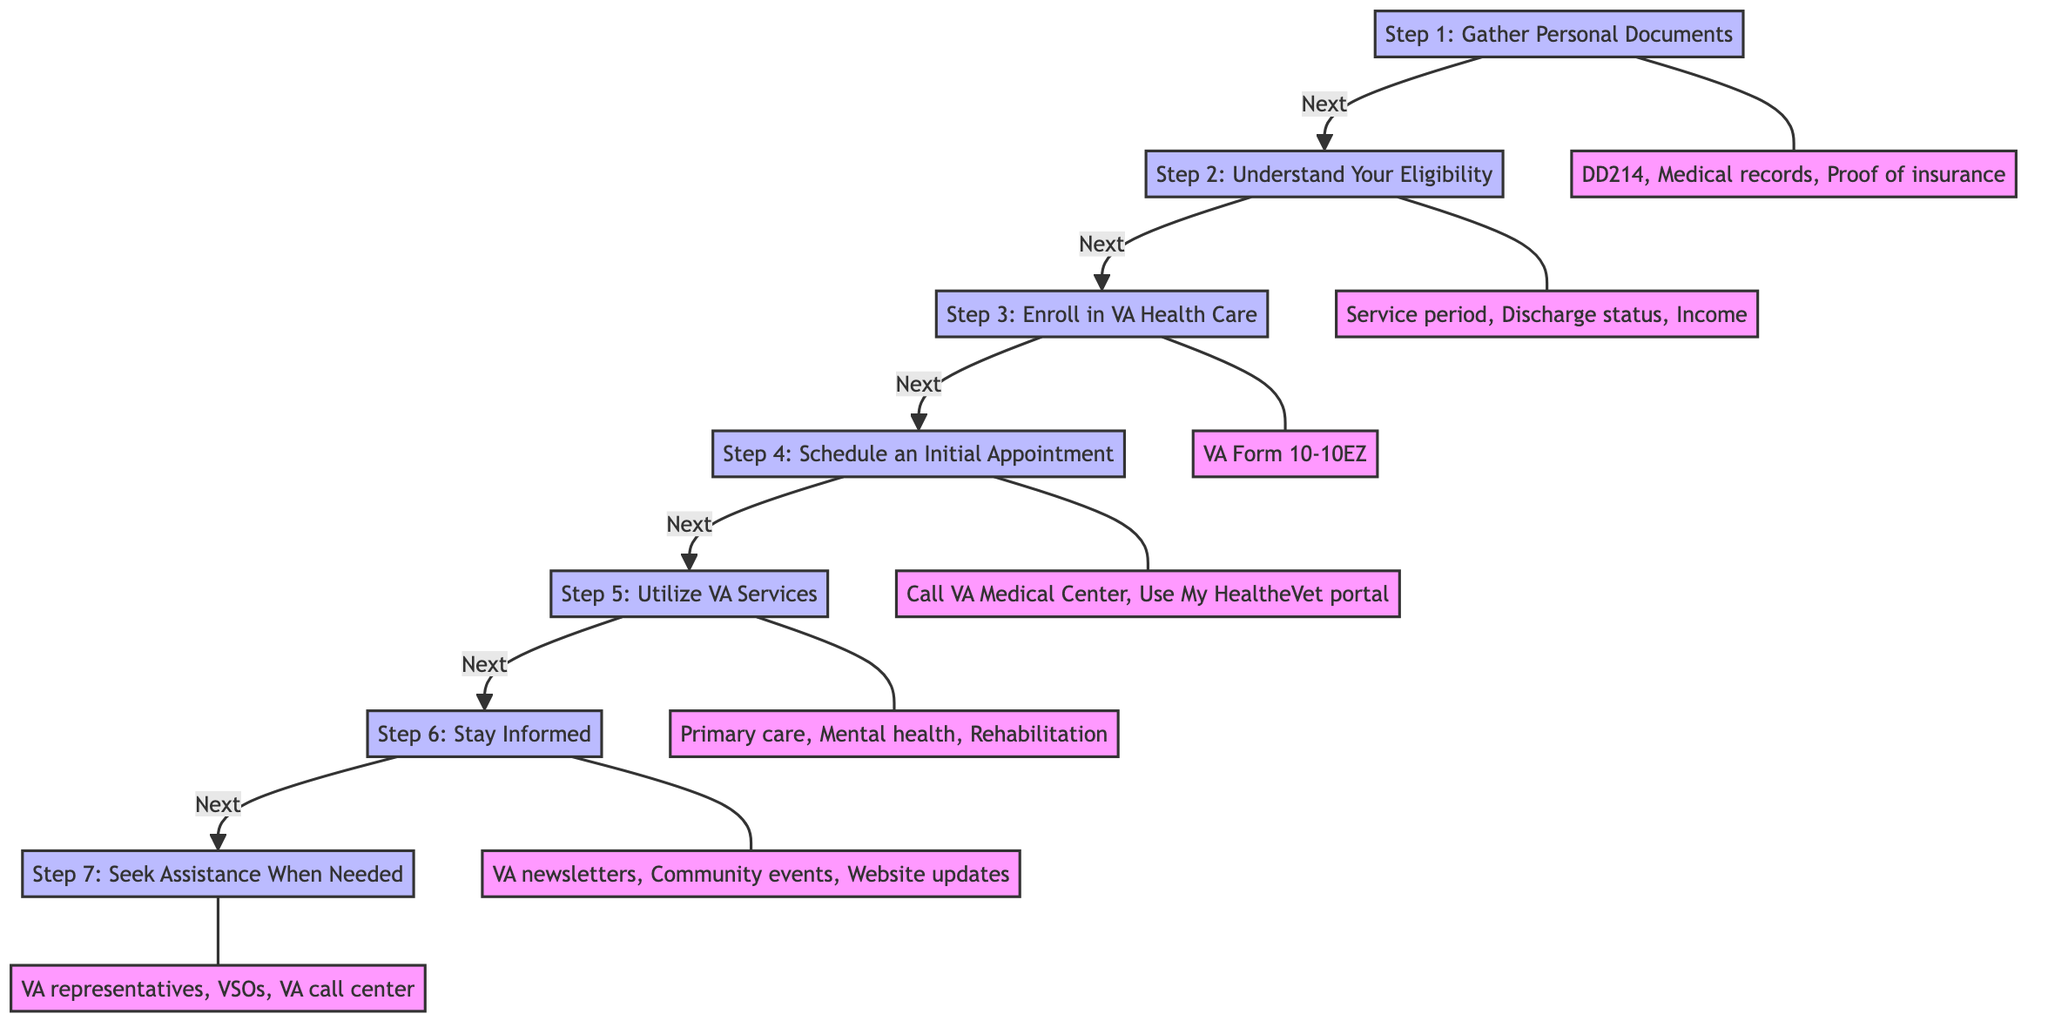What is the first step in the flow chart? The first step is identified as "Step 1: Gather Personal Documents," which is clearly labeled at the bottom of the flow chart.
Answer: Step 1: Gather Personal Documents How many steps are there in the flow chart? The flowchart shows a total of seven steps, each leading sequentially from one to the next, starting from Step 1 and ending at Step 7.
Answer: 7 Which document is mentioned in Step 1? In Step 1, "DD214" is one of the documents explicitly listed. It is grouped with other essential documents that need to be gathered.
Answer: DD214 What is the submission method for enrollment in Step 3? Step 3 provides multiple submission methods for enrollment, and one of them explicitly listed is "Online application."
Answer: Online application What is the purpose of Step 4? The purpose of "Step 4: Schedule an Initial Appointment" is to facilitate scheduling an appointment with a VA primary care provider after enrollment, which is clearly indicated in the node description.
Answer: Schedule an Initial Appointment What do you need to prepare for the appointment in Step 4? For the appointment in Step 4, you need to prepare your "medical history" and "list of current medications," which are detailed in the accompanying information.
Answer: Medical history, list of current medications How can someone seek assistance according to Step 7? According to Step 7, someone can seek assistance by contacting "VA representatives," which is one of the resources specified for getting help navigating the VA health benefits system.
Answer: VA representatives Which step addresses staying informed about VA health benefits? "Step 6: Stay Informed" directly addresses the importance of keeping updated about VA health benefits and services, as highlighted in that step.
Answer: Step 6: Stay Informed What services are accessed in Step 5? Step 5 allows access to "Preventive and primary care," indicating the type of services veterans can utilize under the VA health system.
Answer: Preventive and primary care 